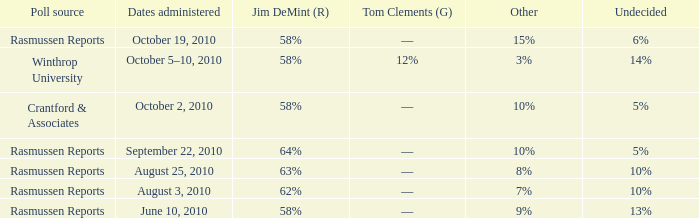What was the vote percentage for alvin green when the other candidate had 9%? 21%. 